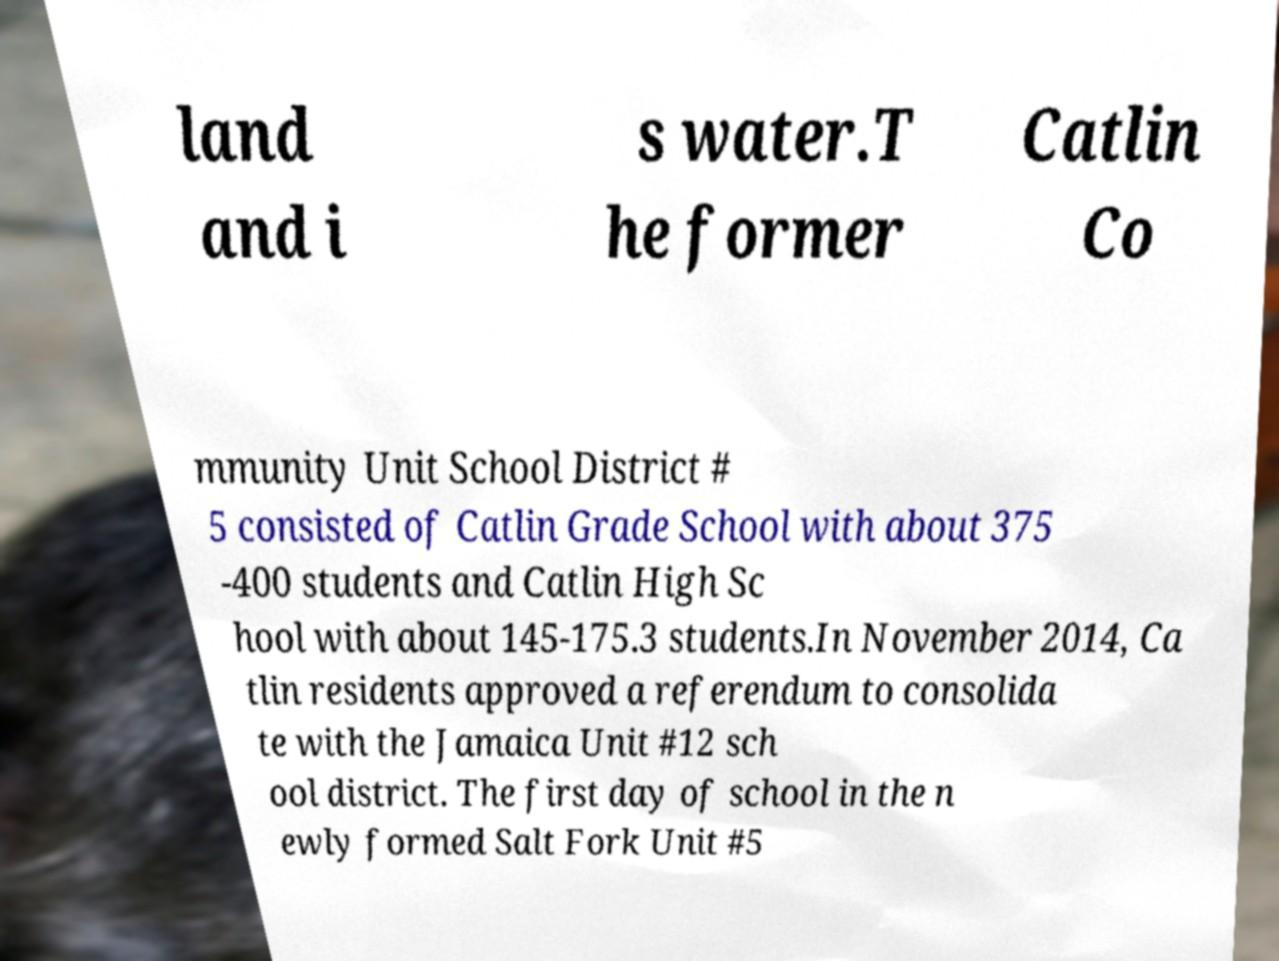Could you extract and type out the text from this image? land and i s water.T he former Catlin Co mmunity Unit School District # 5 consisted of Catlin Grade School with about 375 -400 students and Catlin High Sc hool with about 145-175.3 students.In November 2014, Ca tlin residents approved a referendum to consolida te with the Jamaica Unit #12 sch ool district. The first day of school in the n ewly formed Salt Fork Unit #5 